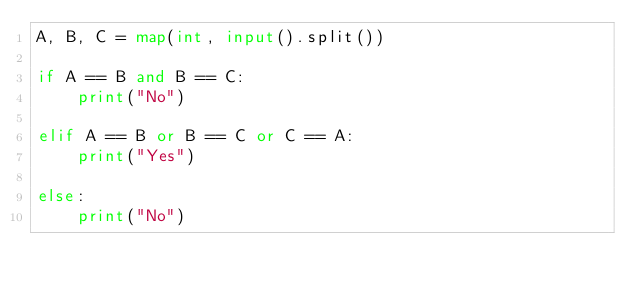<code> <loc_0><loc_0><loc_500><loc_500><_Python_>A, B, C = map(int, input().split())

if A == B and B == C:
    print("No")

elif A == B or B == C or C == A:
    print("Yes")
    
else:
    print("No")</code> 